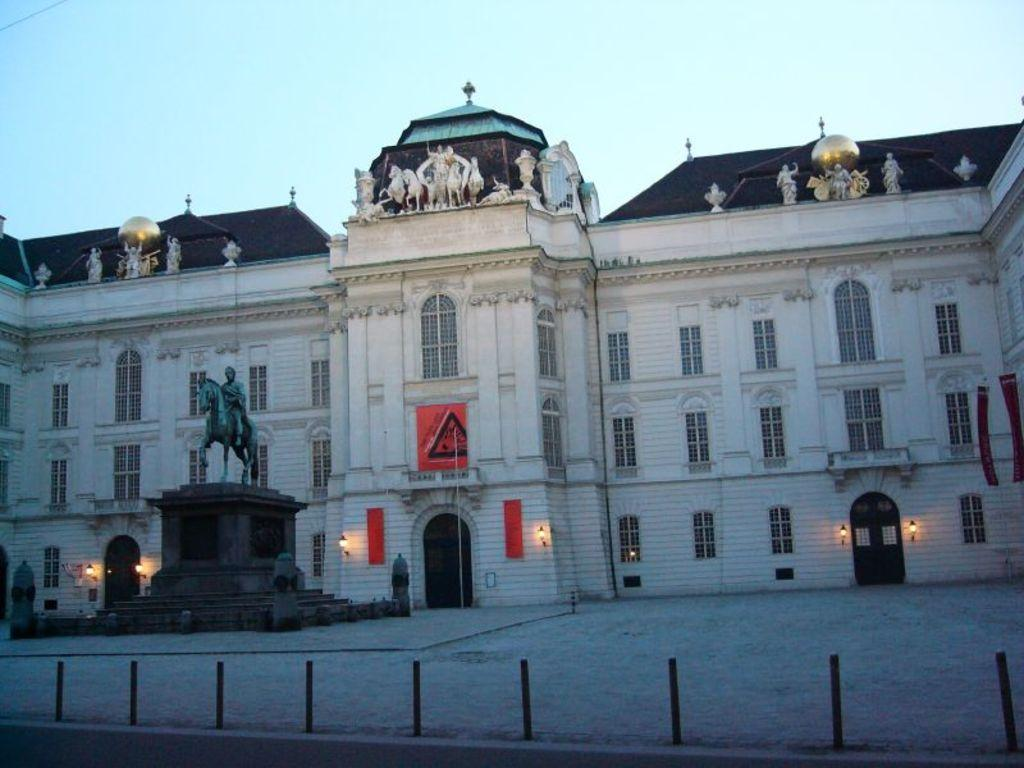What is the main subject in the center of the picture? There is a sculpture in the center of the picture. What else can be seen in the center of the picture besides the sculpture? There are lights and a building in the center of the picture. What is on top of the building? There are sculptures on top of the building. What can be seen in the foreground of the picture? There are poles in the foreground of the picture. What type of coach is parked near the building in the image? There is no coach present in the image; it only features a sculpture, lights, a building, sculptures on top of the building, and poles in the foreground. 